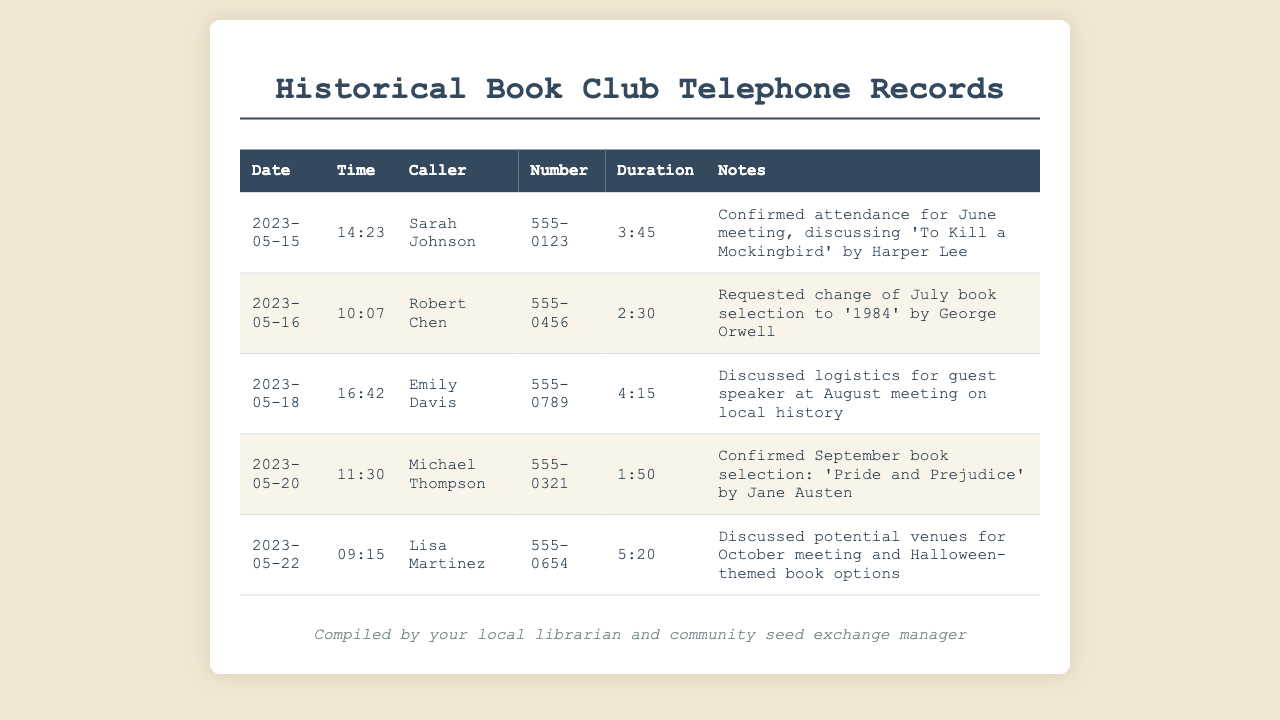What is the date of the call with Sarah Johnson? The date of the call with Sarah Johnson is the first entry listed, which shows when she confirmed her attendance.
Answer: 2023-05-15 What book is discussed for the June meeting? The notes for the call with Sarah Johnson indicate the book for the June meeting.
Answer: To Kill a Mockingbird Who called on May 16? The entry for May 16 lists the caller for that date.
Answer: Robert Chen What was the time of the call with Emily Davis? The time of the call with Emily Davis is recorded as part of her entry.
Answer: 16:42 How long was the call with Michael Thompson? The duration of the call with Michael Thompson is specified in the document.
Answer: 1:50 Which book did Robert Chen propose changing the selection to? The notes from the call with Robert Chen clarify the book he requested for July.
Answer: 1984 What topic was discussed regarding the August meeting? The notes for the call with Emily Davis mention the topic discussed for August.
Answer: Guest speaker on local history Which member confirmed the September book selection? The notes from Michael Thompson's call indicate he confirmed the September book selection.
Answer: Michael Thompson What specific theme was mentioned for potential October books? The last entry notes about potential themes for the October meeting.
Answer: Halloween-themed 